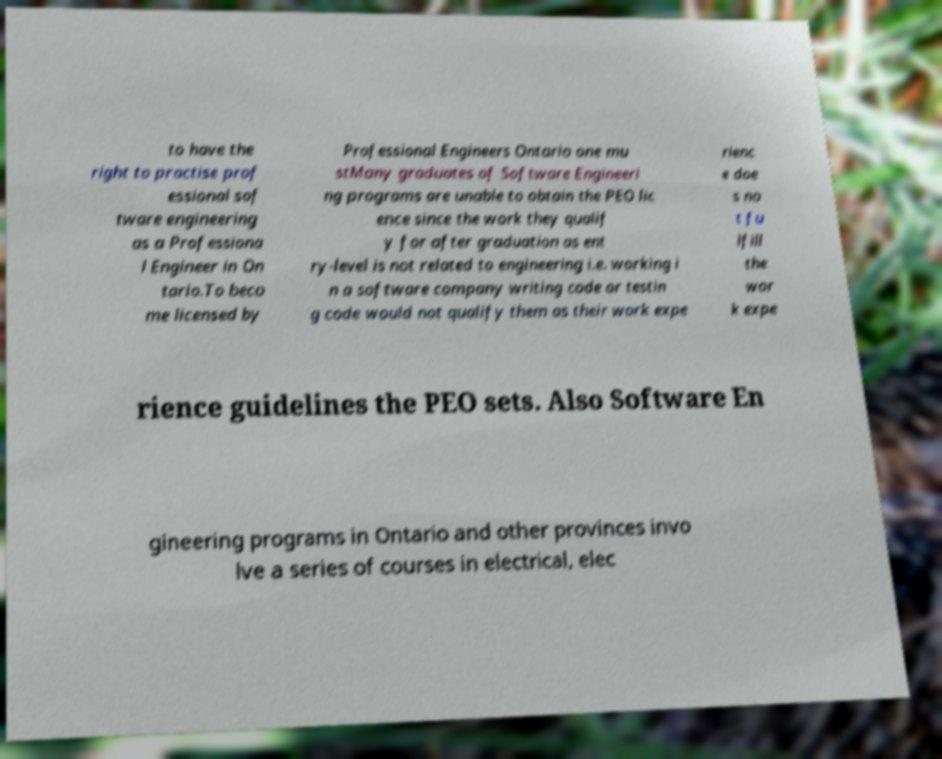Could you assist in decoding the text presented in this image and type it out clearly? to have the right to practise prof essional sof tware engineering as a Professiona l Engineer in On tario.To beco me licensed by Professional Engineers Ontario one mu stMany graduates of Software Engineeri ng programs are unable to obtain the PEO lic ence since the work they qualif y for after graduation as ent ry-level is not related to engineering i.e. working i n a software company writing code or testin g code would not qualify them as their work expe rienc e doe s no t fu lfill the wor k expe rience guidelines the PEO sets. Also Software En gineering programs in Ontario and other provinces invo lve a series of courses in electrical, elec 